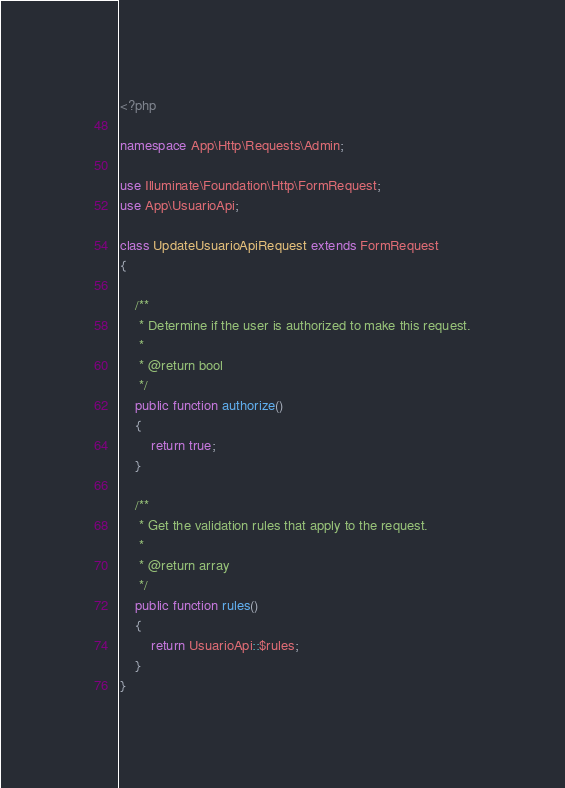<code> <loc_0><loc_0><loc_500><loc_500><_PHP_><?php

namespace App\Http\Requests\Admin;

use Illuminate\Foundation\Http\FormRequest;
use App\UsuarioApi;

class UpdateUsuarioApiRequest extends FormRequest
{

    /**
     * Determine if the user is authorized to make this request.
     *
     * @return bool
     */
    public function authorize()
    {
        return true;
    }

    /**
     * Get the validation rules that apply to the request.
     *
     * @return array
     */
    public function rules()
    {
        return UsuarioApi::$rules;
    }
}
</code> 